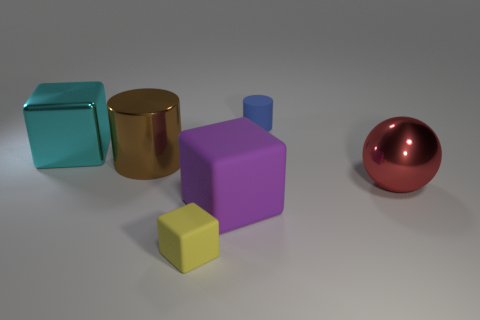What is the shape of the large thing in front of the ball?
Offer a terse response. Cube. How many objects are both left of the purple object and behind the big purple block?
Give a very brief answer. 2. Is there a purple block that has the same material as the large cyan cube?
Your answer should be compact. No. What number of cubes are either small rubber objects or large blue rubber things?
Ensure brevity in your answer.  1. The red thing is what size?
Provide a short and direct response. Large. How many large cyan metallic objects are to the left of the big red metallic thing?
Provide a succinct answer. 1. What is the size of the rubber cube left of the big block in front of the red metallic object?
Ensure brevity in your answer.  Small. Does the shiny object on the right side of the rubber cylinder have the same shape as the tiny matte thing that is to the left of the tiny blue matte cylinder?
Keep it short and to the point. No. There is a large brown object on the left side of the small rubber thing that is behind the brown shiny object; what is its shape?
Your answer should be very brief. Cylinder. There is a thing that is on the right side of the small yellow rubber object and behind the red metallic ball; how big is it?
Make the answer very short. Small. 